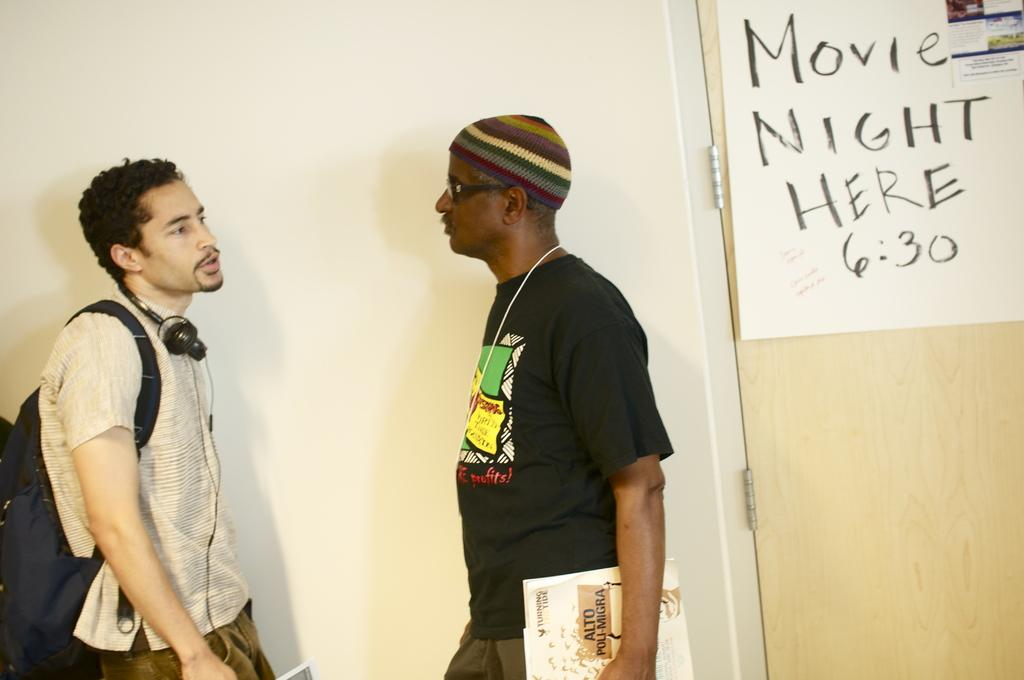How many people are in the foreground of the image? There are two men standing in the foreground of the image. What can be seen in the background of the image? There is a chart on the door in the background of the image. What grade is the noise level in the image? There is no mention of noise or grades in the image, so this question cannot be answered. 